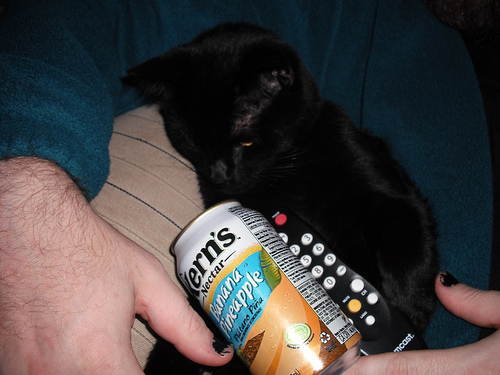Please transcribe the text information in this image. Kern's Vectar Banana Pineapple 9 0 8 2 5 6 3 